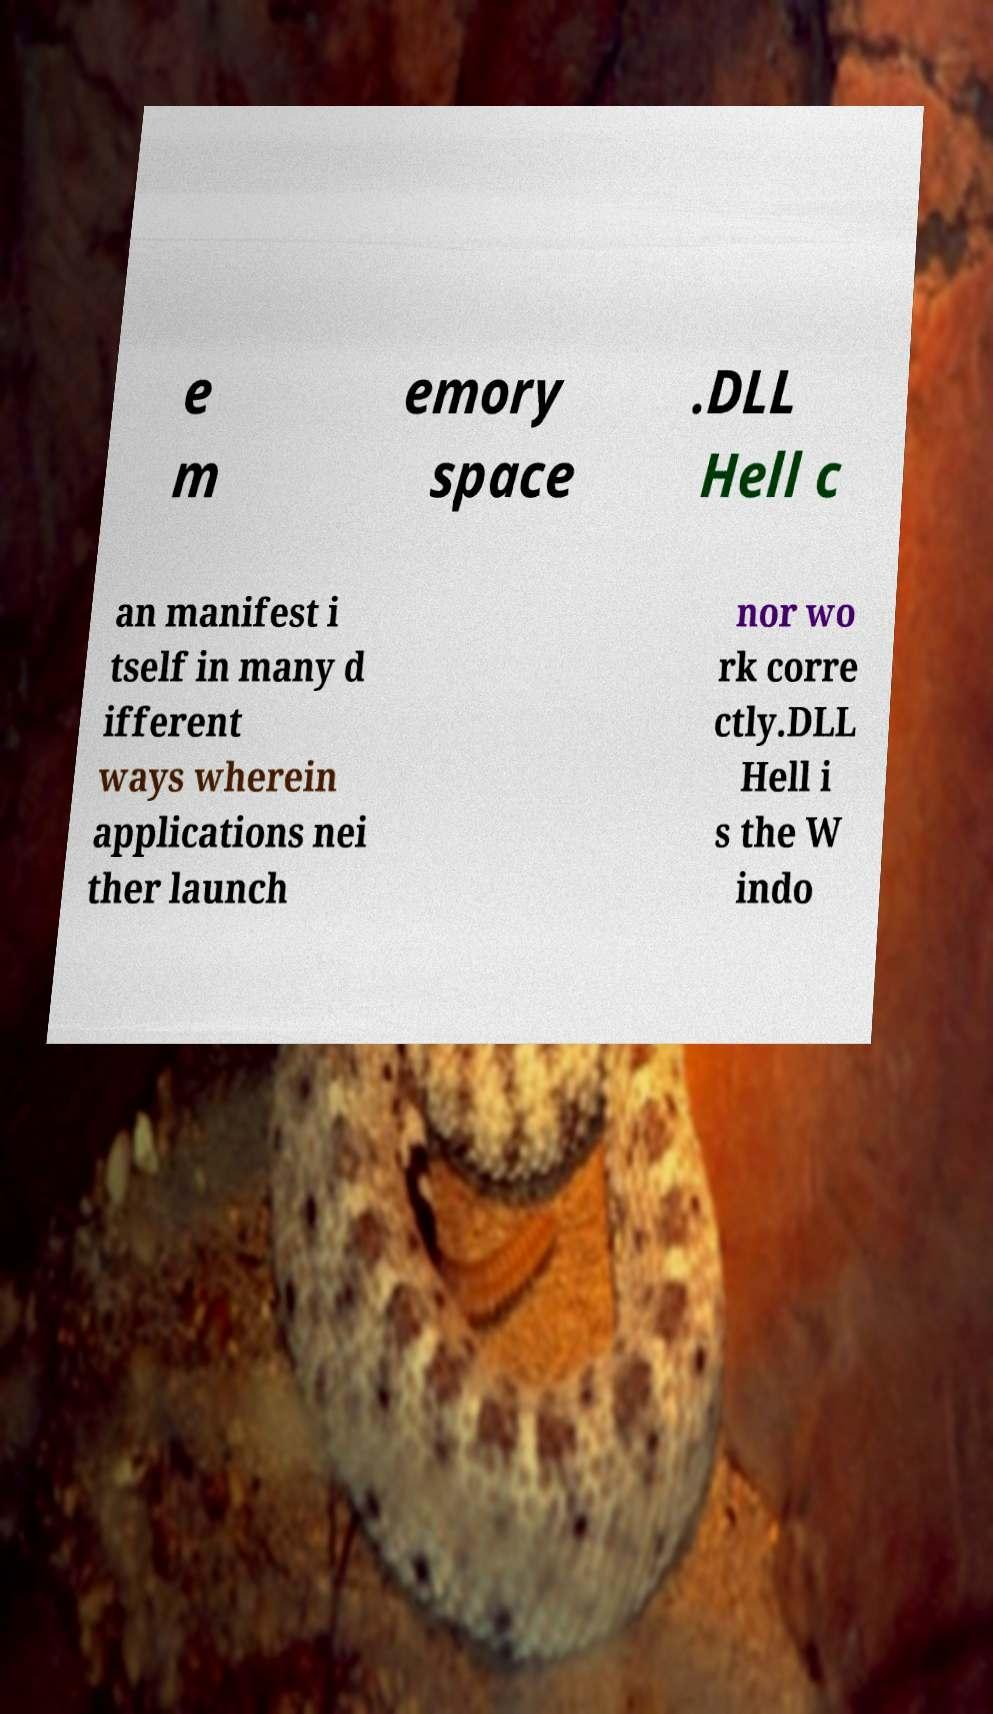Please read and relay the text visible in this image. What does it say? e m emory space .DLL Hell c an manifest i tself in many d ifferent ways wherein applications nei ther launch nor wo rk corre ctly.DLL Hell i s the W indo 